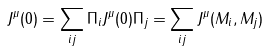<formula> <loc_0><loc_0><loc_500><loc_500>J ^ { \mu } ( 0 ) = \sum _ { i j } \Pi _ { i } J ^ { \mu } ( 0 ) \Pi _ { j } = \sum _ { i j } J ^ { \mu } ( M _ { i } , M _ { j } )</formula> 